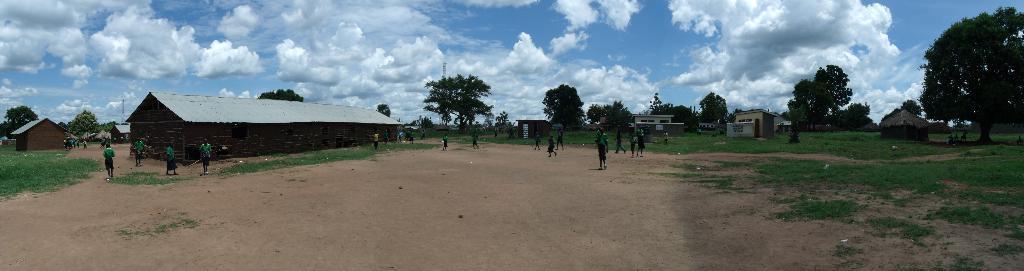Can you describe this image briefly? In this image we can see these people are standing in the ground. Here we can see the wooden houses, trees, towers and sky with clouds in the background. 